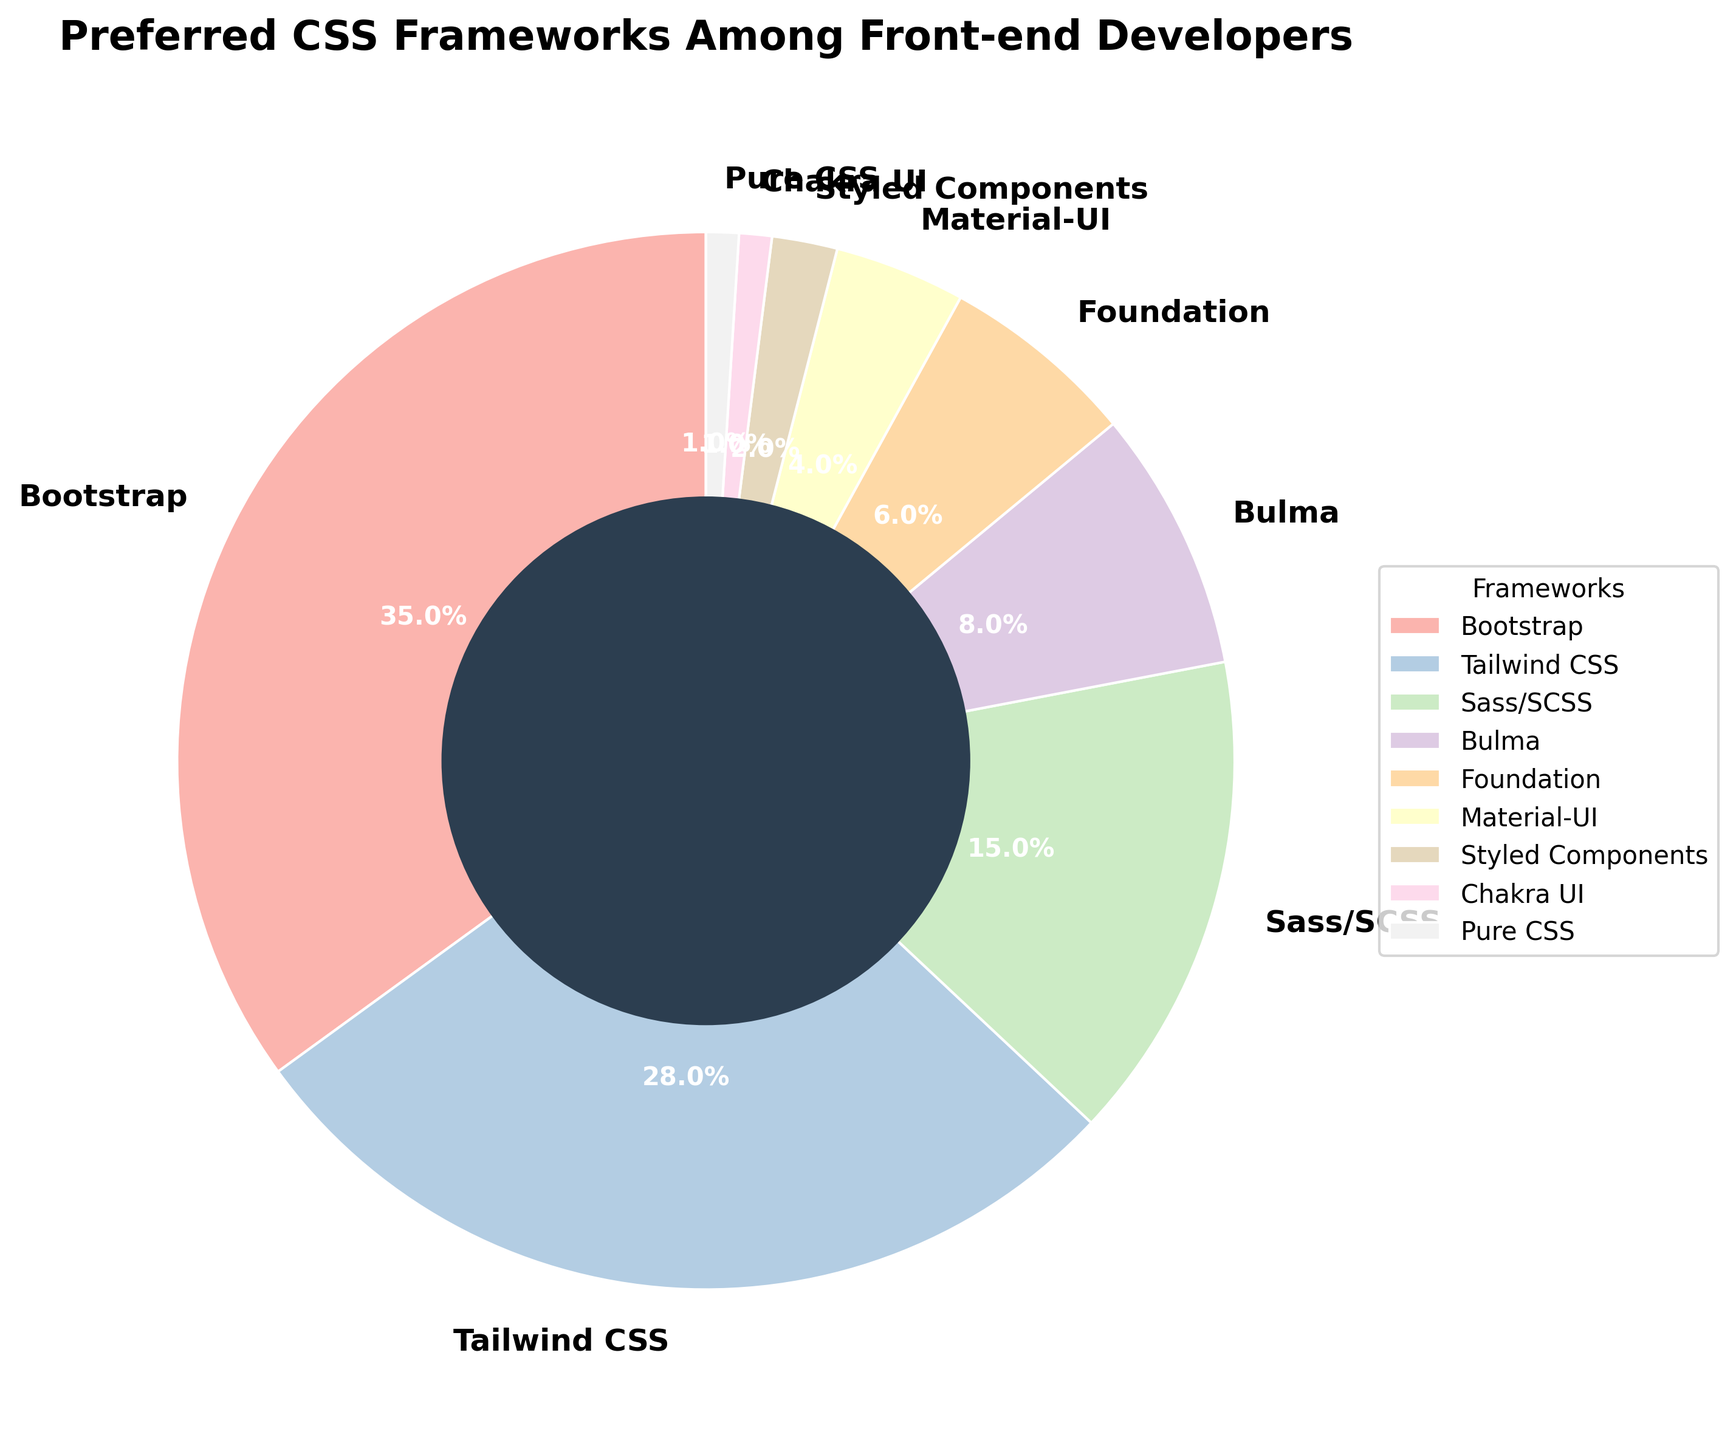What is the most preferred CSS framework among front-end developers? The pie chart shows the percentage breakdown for each CSS framework, and the largest section of the pie chart represents Bootstrap. It has the highest percentage at 35%.
Answer: Bootstrap Which CSS framework is the least popular? The smallest section of the pie chart represents Pure CSS and Chakra UI, both having the smallest percentage at 1%.
Answer: Pure CSS and Chakra UI What is the combined percentage of developers preferring Bootstrap and Tailwind CSS? From the pie chart, Bootstrap has a percentage of 35% and Tailwind CSS has 28%. Summing these values gives 35% + 28% = 63%.
Answer: 63% How many percentage points more popular is Sass/SCSS compared to Bulma? The pie chart shows Sass/SCSS has 15% and Bulma has 8%. The difference is 15% - 8% = 7%.
Answer: 7% Which framework has twice the preference rate of Foundation? Foundation has a preference rate of 6%. Doubled, this is 6% * 2 = 12%. Sass/SCSS has a preference rate closest to this doubled rate, but slightly above at 15%.
Answer: Sass/SCSS How does the popularity of Foundation compare to that of Material-UI? Foundation holds 6% of the preference, while Material-UI holds 4%. Therefore, Foundation is more popular than Material-UI by 2 percentage points.
Answer: Foundation by 2% What is the total percentage of developers who prefer either Material-UI, Styled Components, Chakra UI, or Pure CSS? Material-UI has 4%, Styled Components has 2%, Chakra UI has 1%, and Pure CSS has 1%. Adding these gives 4% + 2% + 1% + 1% = 8%.
Answer: 8% Which CSS framework is represented by a section in pastel color shades? The pie chart uses custom pastel colors for all the sections. Each CSS framework segment is represented in pastel colors continuously across the pie.
Answer: All frameworks If you combine the percentages of Bulma and Foundation, which framework has a similar preference percentage? Bulma has 8% and Foundation has 6%. Sum these to get 8% + 6% = 14%. The closest framework but slightly above is Sass/SCSS with 15%.
Answer: Sass/SCSS What section has a slightly lighter color than Tailwind CSS? The pie chart in pastel tones likely uses a gradient, but based on the order and sizes, Sass/SCSS (which is next in line following Tailwind CSS) could visually appear slightly lighter.
Answer: Sass/SCSS 